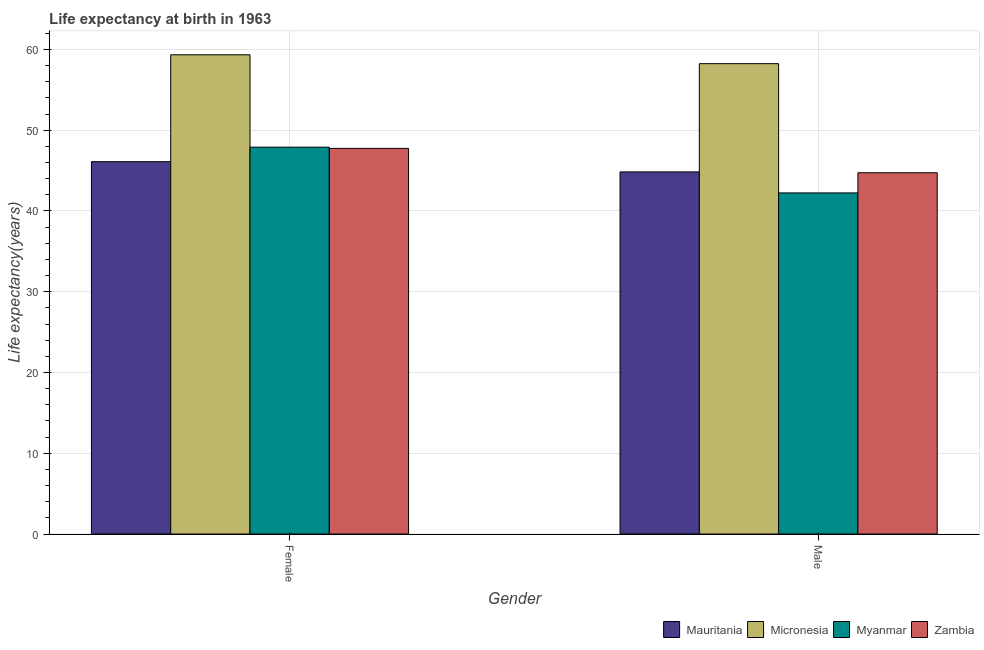How many bars are there on the 2nd tick from the left?
Provide a short and direct response. 4. How many bars are there on the 1st tick from the right?
Offer a terse response. 4. What is the label of the 1st group of bars from the left?
Keep it short and to the point. Female. What is the life expectancy(male) in Mauritania?
Offer a very short reply. 44.84. Across all countries, what is the maximum life expectancy(male)?
Ensure brevity in your answer.  58.24. Across all countries, what is the minimum life expectancy(female)?
Ensure brevity in your answer.  46.11. In which country was the life expectancy(male) maximum?
Your response must be concise. Micronesia. In which country was the life expectancy(female) minimum?
Provide a short and direct response. Mauritania. What is the total life expectancy(male) in the graph?
Ensure brevity in your answer.  190.06. What is the difference between the life expectancy(female) in Micronesia and that in Zambia?
Your response must be concise. 11.59. What is the difference between the life expectancy(female) in Zambia and the life expectancy(male) in Mauritania?
Offer a terse response. 2.91. What is the average life expectancy(female) per country?
Provide a short and direct response. 50.28. What is the difference between the life expectancy(male) and life expectancy(female) in Myanmar?
Provide a succinct answer. -5.67. What is the ratio of the life expectancy(female) in Myanmar to that in Micronesia?
Keep it short and to the point. 0.81. Is the life expectancy(female) in Mauritania less than that in Zambia?
Give a very brief answer. Yes. In how many countries, is the life expectancy(female) greater than the average life expectancy(female) taken over all countries?
Give a very brief answer. 1. What does the 1st bar from the left in Female represents?
Ensure brevity in your answer.  Mauritania. What does the 1st bar from the right in Female represents?
Offer a very short reply. Zambia. How many bars are there?
Keep it short and to the point. 8. How many countries are there in the graph?
Provide a succinct answer. 4. Are the values on the major ticks of Y-axis written in scientific E-notation?
Your response must be concise. No. Does the graph contain any zero values?
Offer a terse response. No. Does the graph contain grids?
Offer a terse response. Yes. Where does the legend appear in the graph?
Your answer should be compact. Bottom right. How many legend labels are there?
Offer a very short reply. 4. How are the legend labels stacked?
Make the answer very short. Horizontal. What is the title of the graph?
Provide a succinct answer. Life expectancy at birth in 1963. What is the label or title of the Y-axis?
Offer a very short reply. Life expectancy(years). What is the Life expectancy(years) of Mauritania in Female?
Your answer should be very brief. 46.11. What is the Life expectancy(years) in Micronesia in Female?
Your response must be concise. 59.34. What is the Life expectancy(years) in Myanmar in Female?
Your answer should be compact. 47.91. What is the Life expectancy(years) in Zambia in Female?
Provide a short and direct response. 47.75. What is the Life expectancy(years) of Mauritania in Male?
Ensure brevity in your answer.  44.84. What is the Life expectancy(years) of Micronesia in Male?
Your answer should be compact. 58.24. What is the Life expectancy(years) of Myanmar in Male?
Give a very brief answer. 42.24. What is the Life expectancy(years) in Zambia in Male?
Make the answer very short. 44.74. Across all Gender, what is the maximum Life expectancy(years) in Mauritania?
Offer a very short reply. 46.11. Across all Gender, what is the maximum Life expectancy(years) in Micronesia?
Provide a short and direct response. 59.34. Across all Gender, what is the maximum Life expectancy(years) in Myanmar?
Provide a succinct answer. 47.91. Across all Gender, what is the maximum Life expectancy(years) in Zambia?
Offer a very short reply. 47.75. Across all Gender, what is the minimum Life expectancy(years) of Mauritania?
Make the answer very short. 44.84. Across all Gender, what is the minimum Life expectancy(years) in Micronesia?
Make the answer very short. 58.24. Across all Gender, what is the minimum Life expectancy(years) of Myanmar?
Your answer should be compact. 42.24. Across all Gender, what is the minimum Life expectancy(years) in Zambia?
Ensure brevity in your answer.  44.74. What is the total Life expectancy(years) of Mauritania in the graph?
Your answer should be very brief. 90.95. What is the total Life expectancy(years) of Micronesia in the graph?
Your answer should be very brief. 117.59. What is the total Life expectancy(years) in Myanmar in the graph?
Keep it short and to the point. 90.15. What is the total Life expectancy(years) of Zambia in the graph?
Provide a succinct answer. 92.49. What is the difference between the Life expectancy(years) in Mauritania in Female and that in Male?
Your answer should be very brief. 1.27. What is the difference between the Life expectancy(years) in Micronesia in Female and that in Male?
Provide a succinct answer. 1.1. What is the difference between the Life expectancy(years) of Myanmar in Female and that in Male?
Provide a succinct answer. 5.67. What is the difference between the Life expectancy(years) in Zambia in Female and that in Male?
Keep it short and to the point. 3.02. What is the difference between the Life expectancy(years) of Mauritania in Female and the Life expectancy(years) of Micronesia in Male?
Ensure brevity in your answer.  -12.13. What is the difference between the Life expectancy(years) in Mauritania in Female and the Life expectancy(years) in Myanmar in Male?
Offer a very short reply. 3.87. What is the difference between the Life expectancy(years) of Mauritania in Female and the Life expectancy(years) of Zambia in Male?
Provide a succinct answer. 1.37. What is the difference between the Life expectancy(years) of Micronesia in Female and the Life expectancy(years) of Myanmar in Male?
Provide a short and direct response. 17.11. What is the difference between the Life expectancy(years) in Micronesia in Female and the Life expectancy(years) in Zambia in Male?
Your response must be concise. 14.61. What is the difference between the Life expectancy(years) of Myanmar in Female and the Life expectancy(years) of Zambia in Male?
Give a very brief answer. 3.17. What is the average Life expectancy(years) of Mauritania per Gender?
Ensure brevity in your answer.  45.48. What is the average Life expectancy(years) in Micronesia per Gender?
Offer a very short reply. 58.8. What is the average Life expectancy(years) of Myanmar per Gender?
Ensure brevity in your answer.  45.07. What is the average Life expectancy(years) of Zambia per Gender?
Your answer should be compact. 46.25. What is the difference between the Life expectancy(years) of Mauritania and Life expectancy(years) of Micronesia in Female?
Offer a terse response. -13.23. What is the difference between the Life expectancy(years) in Mauritania and Life expectancy(years) in Myanmar in Female?
Provide a short and direct response. -1.8. What is the difference between the Life expectancy(years) in Mauritania and Life expectancy(years) in Zambia in Female?
Your response must be concise. -1.64. What is the difference between the Life expectancy(years) of Micronesia and Life expectancy(years) of Myanmar in Female?
Keep it short and to the point. 11.44. What is the difference between the Life expectancy(years) of Micronesia and Life expectancy(years) of Zambia in Female?
Your answer should be compact. 11.59. What is the difference between the Life expectancy(years) of Myanmar and Life expectancy(years) of Zambia in Female?
Offer a terse response. 0.15. What is the difference between the Life expectancy(years) in Mauritania and Life expectancy(years) in Micronesia in Male?
Offer a very short reply. -13.4. What is the difference between the Life expectancy(years) in Mauritania and Life expectancy(years) in Myanmar in Male?
Make the answer very short. 2.6. What is the difference between the Life expectancy(years) in Mauritania and Life expectancy(years) in Zambia in Male?
Give a very brief answer. 0.1. What is the difference between the Life expectancy(years) of Micronesia and Life expectancy(years) of Myanmar in Male?
Provide a short and direct response. 16. What is the difference between the Life expectancy(years) in Micronesia and Life expectancy(years) in Zambia in Male?
Your answer should be very brief. 13.51. What is the difference between the Life expectancy(years) in Myanmar and Life expectancy(years) in Zambia in Male?
Give a very brief answer. -2.5. What is the ratio of the Life expectancy(years) in Mauritania in Female to that in Male?
Provide a succinct answer. 1.03. What is the ratio of the Life expectancy(years) in Micronesia in Female to that in Male?
Make the answer very short. 1.02. What is the ratio of the Life expectancy(years) of Myanmar in Female to that in Male?
Offer a very short reply. 1.13. What is the ratio of the Life expectancy(years) in Zambia in Female to that in Male?
Keep it short and to the point. 1.07. What is the difference between the highest and the second highest Life expectancy(years) in Mauritania?
Offer a terse response. 1.27. What is the difference between the highest and the second highest Life expectancy(years) of Micronesia?
Offer a very short reply. 1.1. What is the difference between the highest and the second highest Life expectancy(years) of Myanmar?
Offer a terse response. 5.67. What is the difference between the highest and the second highest Life expectancy(years) of Zambia?
Your answer should be compact. 3.02. What is the difference between the highest and the lowest Life expectancy(years) of Mauritania?
Your response must be concise. 1.27. What is the difference between the highest and the lowest Life expectancy(years) in Myanmar?
Make the answer very short. 5.67. What is the difference between the highest and the lowest Life expectancy(years) of Zambia?
Give a very brief answer. 3.02. 